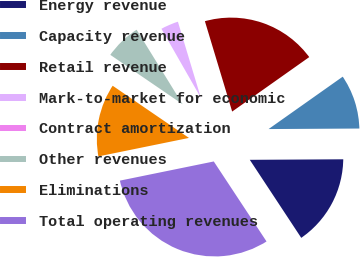Convert chart. <chart><loc_0><loc_0><loc_500><loc_500><pie_chart><fcel>Energy revenue<fcel>Capacity revenue<fcel>Retail revenue<fcel>Mark-to-market for economic<fcel>Contract amortization<fcel>Other revenues<fcel>Eliminations<fcel>Total operating revenues<nl><fcel>15.81%<fcel>9.7%<fcel>19.87%<fcel>3.6%<fcel>0.54%<fcel>6.65%<fcel>12.75%<fcel>31.07%<nl></chart> 